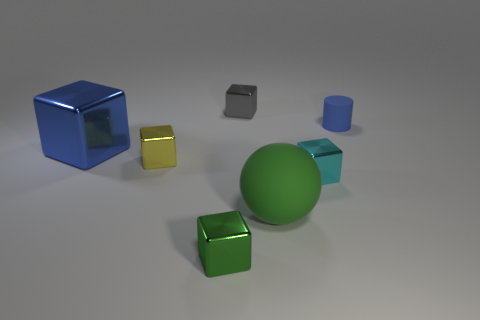What number of other large matte spheres are the same color as the rubber ball?
Give a very brief answer. 0. What size is the thing that is on the right side of the green matte sphere and in front of the blue block?
Provide a short and direct response. Small. Is the number of green objects right of the green rubber sphere less than the number of green spheres?
Your answer should be very brief. Yes. Do the blue block and the gray cube have the same material?
Ensure brevity in your answer.  Yes. What number of objects are gray metallic balls or blue objects?
Provide a succinct answer. 2. What number of large green balls have the same material as the gray cube?
Offer a very short reply. 0. There is a gray metal object that is the same shape as the small cyan object; what size is it?
Give a very brief answer. Small. There is a tiny green thing; are there any tiny blue cylinders to the right of it?
Provide a short and direct response. Yes. What is the material of the cyan block?
Give a very brief answer. Metal. There is a small shiny thing that is to the left of the small green metallic object; is its color the same as the large metallic thing?
Keep it short and to the point. No. 